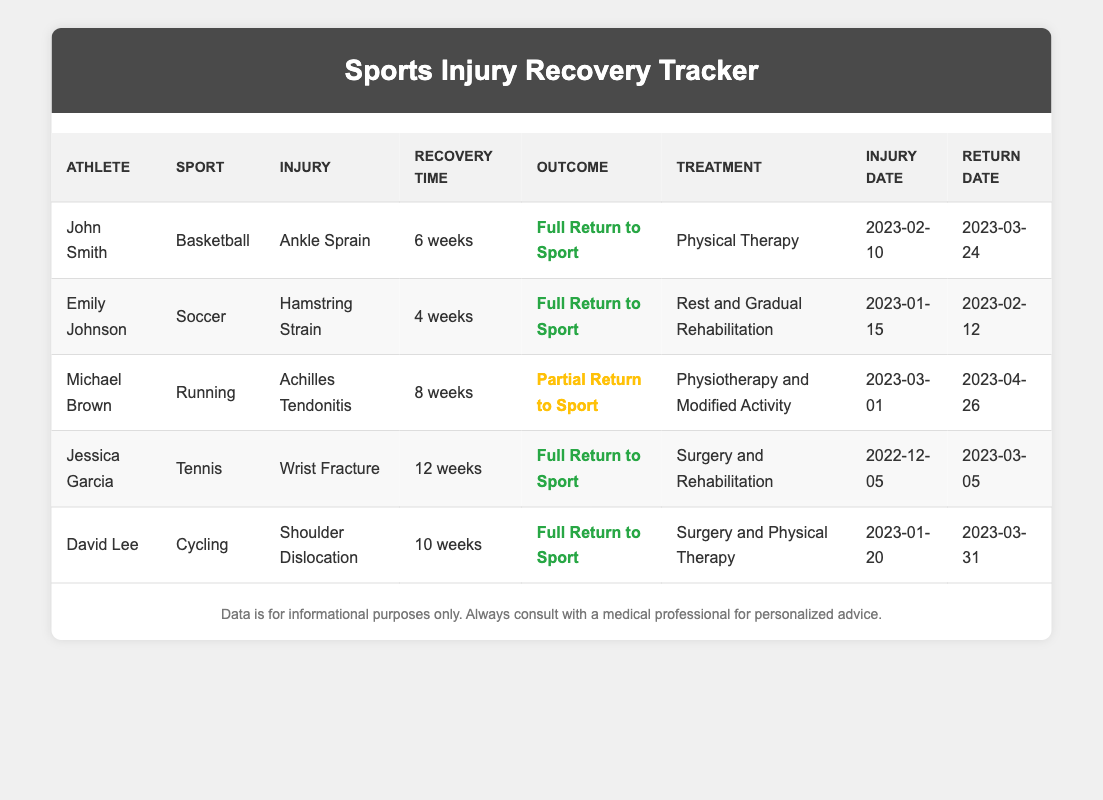What is the recovery time for Emily Johnson? Emily Johnson's recovery time is listed in the table, specifically under the "Recovery Time" column for her row. It shows "4 weeks" as the recovery time for her hamstring strain injury.
Answer: 4 weeks Which athlete had the longest recovery time? To find the athlete with the longest recovery time, we can compare the recovery times listed for each athlete: John Smith (6 weeks), Emily Johnson (4 weeks), Michael Brown (8 weeks), Jessica Garcia (12 weeks), and David Lee (10 weeks). Among these, Jessica Garcia has the longest recovery time of 12 weeks.
Answer: Jessica Garcia Did Michael Brown achieve a full return to his sport? Checking the "Outcome" column for Michael Brown, we see that he has a "Partial Return to Sport," which indicates that he did not achieve a full return.
Answer: No What was the average recovery time for all athletes listed? To calculate the average recovery time, we sum the recovery times: 6 (John) + 4 (Emily) + 8 (Michael) + 12 (Jessica) + 10 (David) = 40 weeks. There are 5 athletes, so the average is 40/5 = 8 weeks.
Answer: 8 weeks How many athletes returned to their sport after 8 weeks or less? We check the recovery times against the cutoff of 8 weeks. John Smith (6 weeks), Emily Johnson (4 weeks), and Michael Brown (8 weeks) all fit this criterion. Therefore, there are three athletes who returned after 8 weeks or less.
Answer: 3 athletes What was the treatment method for Jessica Garcia? To find the treatment method for Jessica Garcia, we look at her row, specifically the "Treatment" column, which states "Surgery and Rehabilitation."
Answer: Surgery and Rehabilitation Was there any athlete that required physical therapy as a treatment method? The table must be scanned for any mention of "Physical Therapy" in the treatment column. Both John Smith and David Lee had "Physical Therapy" as part of their treatment. Thus, the answer to the question is yes, there were athletes requiring physical therapy.
Answer: Yes Who sustained an injury on January 15, 2023? This date can be located in the "Injury Date" column. Only Emily Johnson is listed with the date of January 15, 2023, next to her name.
Answer: Emily Johnson 